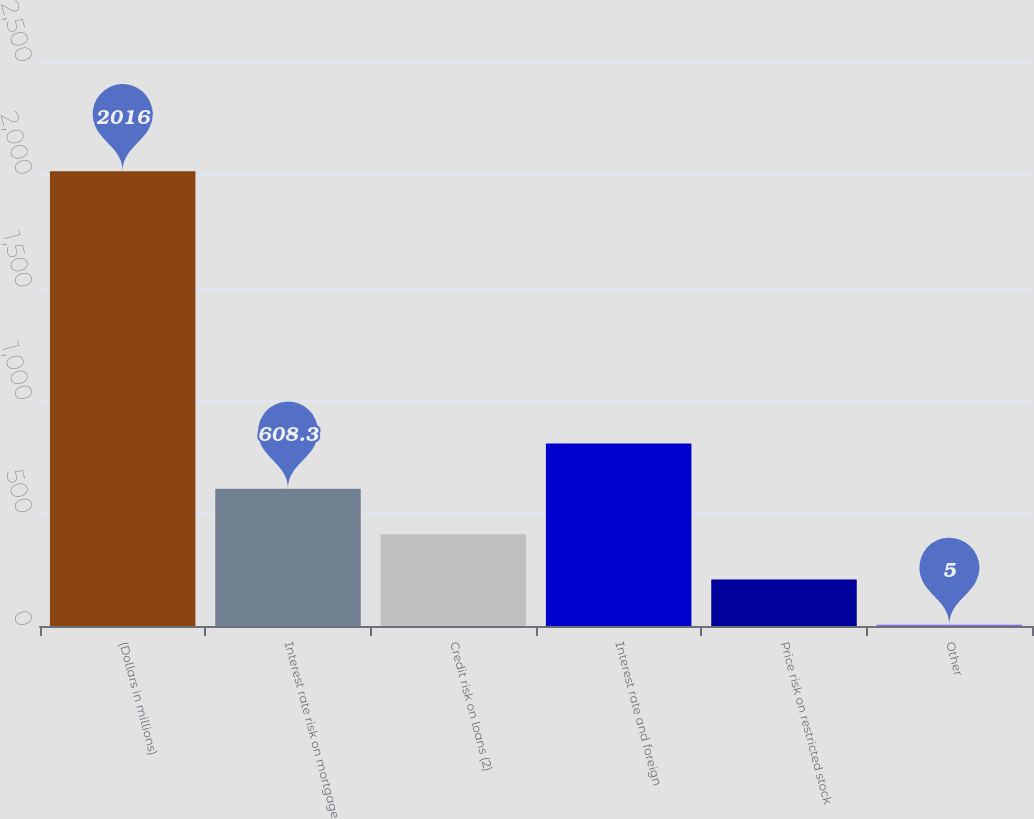Convert chart. <chart><loc_0><loc_0><loc_500><loc_500><bar_chart><fcel>(Dollars in millions)<fcel>Interest rate risk on mortgage<fcel>Credit risk on loans (2)<fcel>Interest rate and foreign<fcel>Price risk on restricted stock<fcel>Other<nl><fcel>2016<fcel>608.3<fcel>407.2<fcel>809.4<fcel>206.1<fcel>5<nl></chart> 